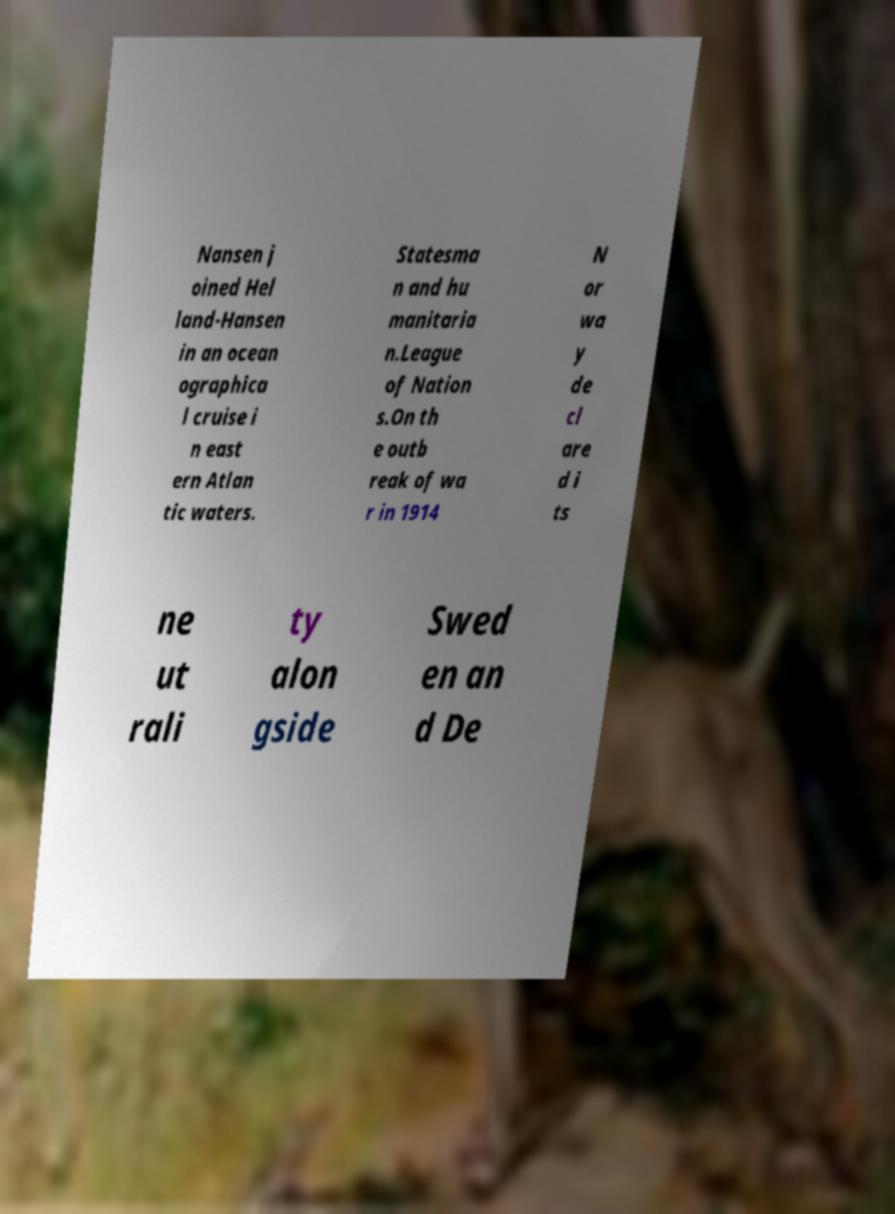Can you accurately transcribe the text from the provided image for me? Nansen j oined Hel land-Hansen in an ocean ographica l cruise i n east ern Atlan tic waters. Statesma n and hu manitaria n.League of Nation s.On th e outb reak of wa r in 1914 N or wa y de cl are d i ts ne ut rali ty alon gside Swed en an d De 